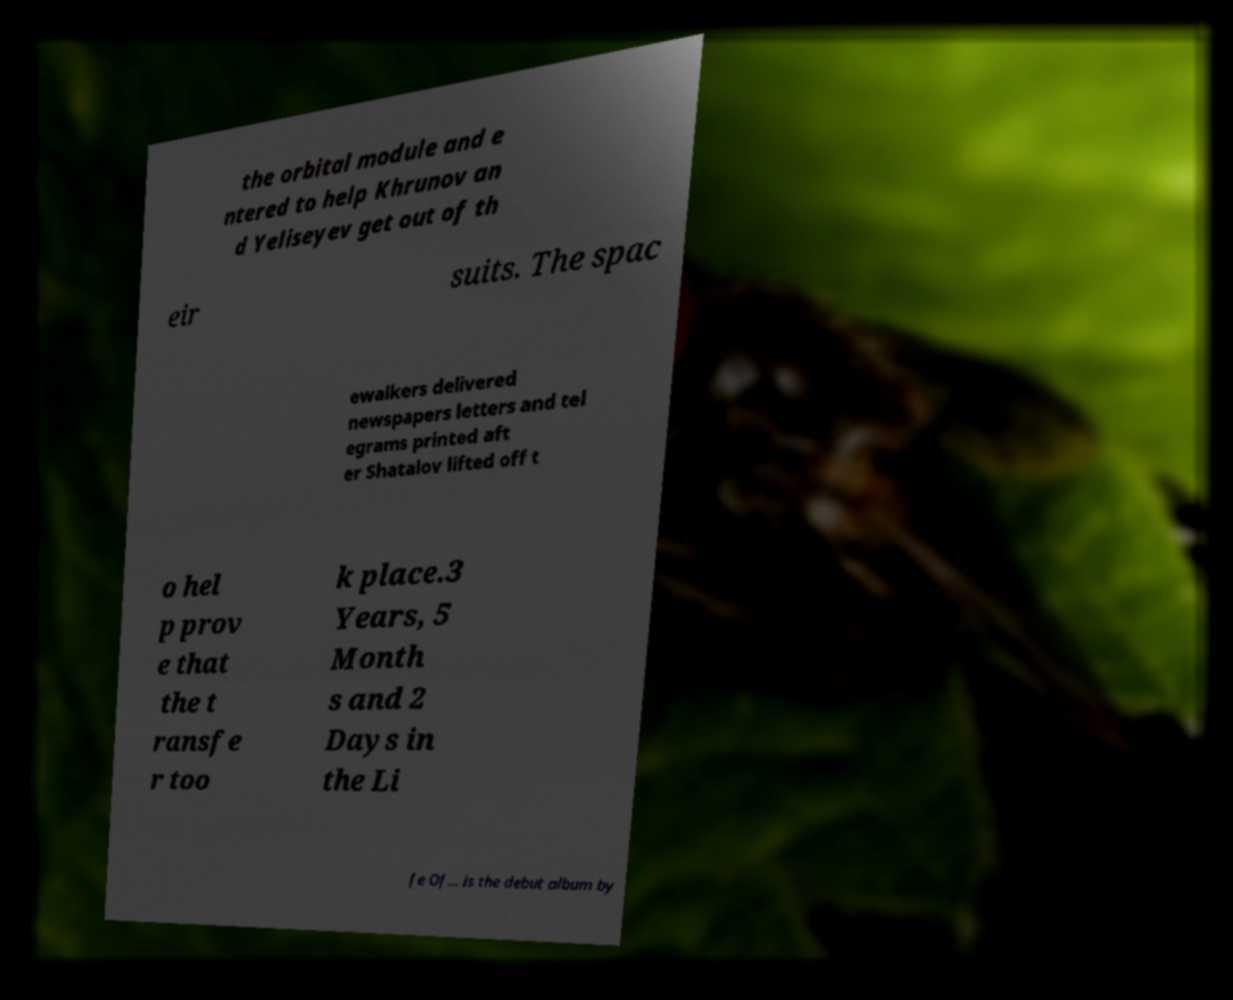What messages or text are displayed in this image? I need them in a readable, typed format. the orbital module and e ntered to help Khrunov an d Yeliseyev get out of th eir suits. The spac ewalkers delivered newspapers letters and tel egrams printed aft er Shatalov lifted off t o hel p prov e that the t ransfe r too k place.3 Years, 5 Month s and 2 Days in the Li fe Of... is the debut album by 